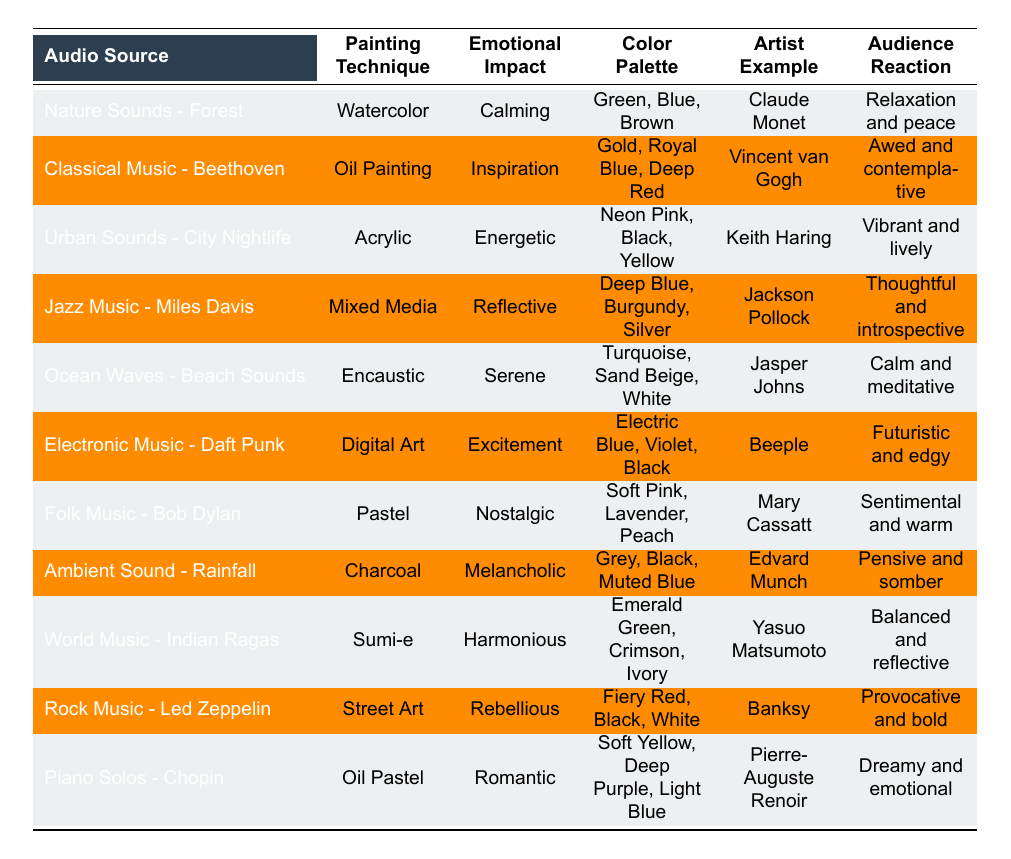What is the emotional impact of the painting technique "Watercolor"? The table indicates that the emotional impact associated with Watercolor is "Calming."
Answer: Calming Which artist is associated with the use of "Electronic Music - Daft Punk" in digital art? According to the table, the artist associated with this audio source in digital art is "Beeple."
Answer: Beeple What color palette is used in "Oil Painting" influenced by "Classical Music - Beethoven"? The color palette for Oil Painting under this audio source is "Gold, Royal Blue, Deep Red."
Answer: Gold, Royal Blue, Deep Red Is the emotional impact of "Rock Music - Led Zeppelin" for Street Art considered rebellious? The table confirms that the emotional impact for this combination is indeed "Rebellious."
Answer: Yes How many painting techniques have an emotional impact categorized as "Calming"? The table lists only one painting technique with a calming impact, which is Watercolor.
Answer: 1 Which painting technique has the color palette "Electric Blue, Violet, Black"? The table shows that this color palette is used in "Digital Art."
Answer: Digital Art What is the audience reaction to the painting influenced by "Ocean Waves - Beach Sounds"? The table states that the audience reaction is "Calm and meditative."
Answer: Calm and meditative Which audio source is linked to a nostalgic emotional impact and pastel painting technique? The table indicates that "Folk Music - Bob Dylan" is linked to this emotional impact and technique.
Answer: Folk Music - Bob Dylan How many audio sources in the table evoke an emotional impact related to serenity or calmness? The two audio sources evoking serenity or calmness are "Nature Sounds - Forest" (Calming) and "Ocean Waves - Beach Sounds" (Serene).
Answer: 2 What is the emotional impact of "Ambient Sound - Rainfall" when using Charcoal as a painting technique? The emotional impact for this audio source and technique combination is "Melancholic."
Answer: Melancholic Which painting technique associated with "Jazz Music - Miles Davis" has the color palette "Deep Blue, Burgundy, Silver"? The technique is "Mixed Media."
Answer: Mixed Media 